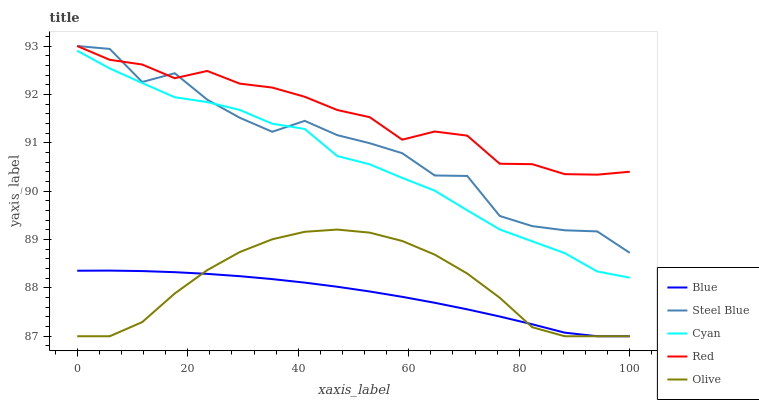Does Blue have the minimum area under the curve?
Answer yes or no. Yes. Does Red have the maximum area under the curve?
Answer yes or no. Yes. Does Cyan have the minimum area under the curve?
Answer yes or no. No. Does Cyan have the maximum area under the curve?
Answer yes or no. No. Is Blue the smoothest?
Answer yes or no. Yes. Is Steel Blue the roughest?
Answer yes or no. Yes. Is Cyan the smoothest?
Answer yes or no. No. Is Cyan the roughest?
Answer yes or no. No. Does Cyan have the lowest value?
Answer yes or no. No. Does Red have the highest value?
Answer yes or no. Yes. Does Cyan have the highest value?
Answer yes or no. No. Is Olive less than Cyan?
Answer yes or no. Yes. Is Steel Blue greater than Olive?
Answer yes or no. Yes. Does Steel Blue intersect Red?
Answer yes or no. Yes. Is Steel Blue less than Red?
Answer yes or no. No. Is Steel Blue greater than Red?
Answer yes or no. No. Does Olive intersect Cyan?
Answer yes or no. No. 